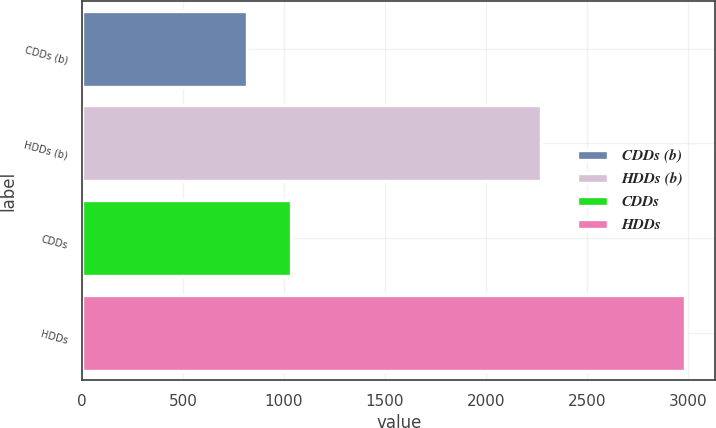<chart> <loc_0><loc_0><loc_500><loc_500><bar_chart><fcel>CDDs (b)<fcel>HDDs (b)<fcel>CDDs<fcel>HDDs<nl><fcel>819<fcel>2272<fcel>1035.9<fcel>2988<nl></chart> 